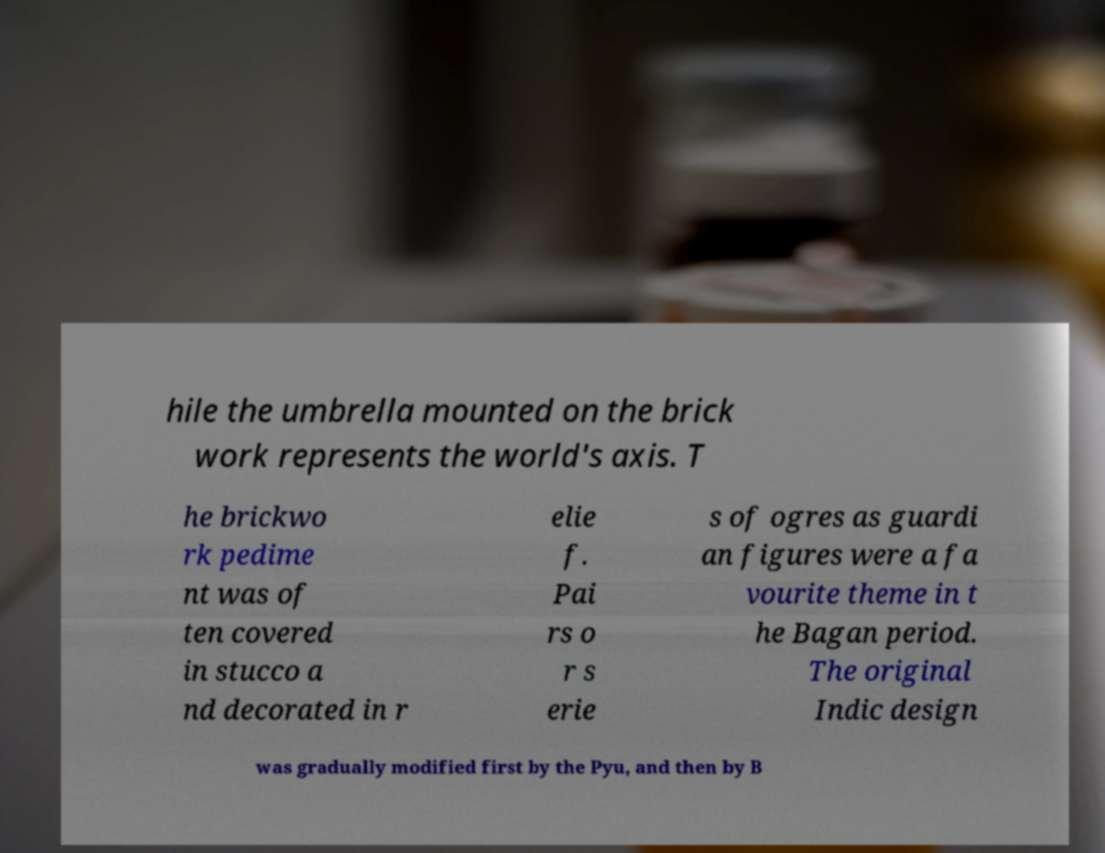Can you accurately transcribe the text from the provided image for me? hile the umbrella mounted on the brick work represents the world's axis. T he brickwo rk pedime nt was of ten covered in stucco a nd decorated in r elie f. Pai rs o r s erie s of ogres as guardi an figures were a fa vourite theme in t he Bagan period. The original Indic design was gradually modified first by the Pyu, and then by B 